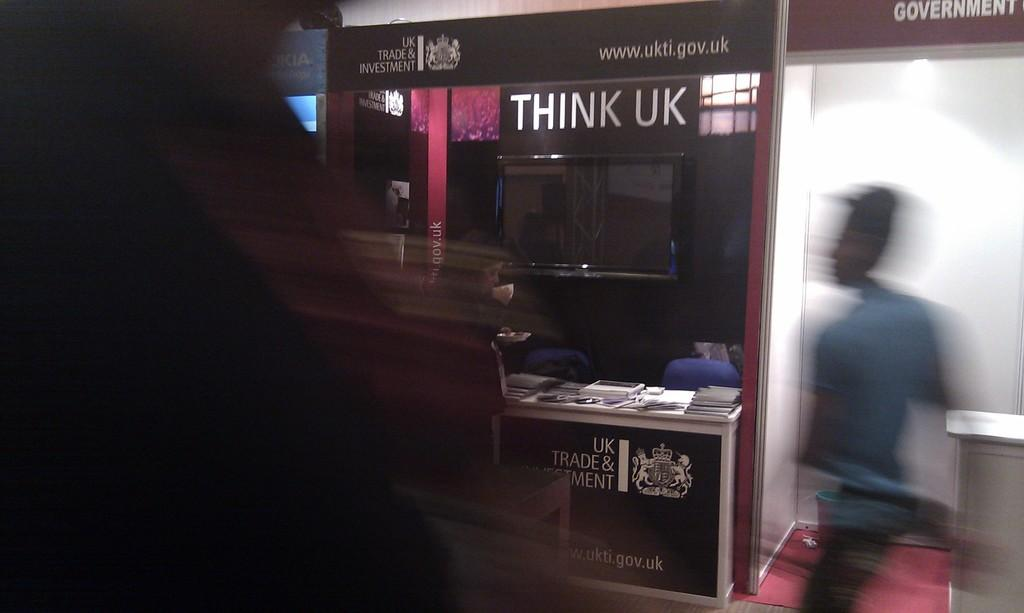<image>
Relay a brief, clear account of the picture shown. A man is walking pass a government counter towards a UK Trade and investment counter. 